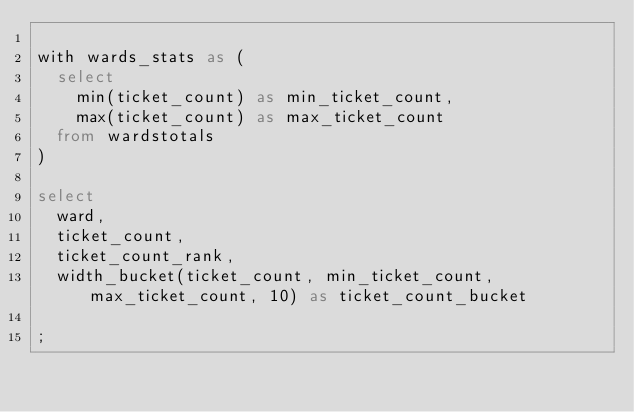Convert code to text. <code><loc_0><loc_0><loc_500><loc_500><_SQL_>
with wards_stats as (
  select
    min(ticket_count) as min_ticket_count,
    max(ticket_count) as max_ticket_count
  from wardstotals
)

select
  ward,
  ticket_count,
  ticket_count_rank,
  width_bucket(ticket_count, min_ticket_count, max_ticket_count, 10) as ticket_count_bucket

;
</code> 